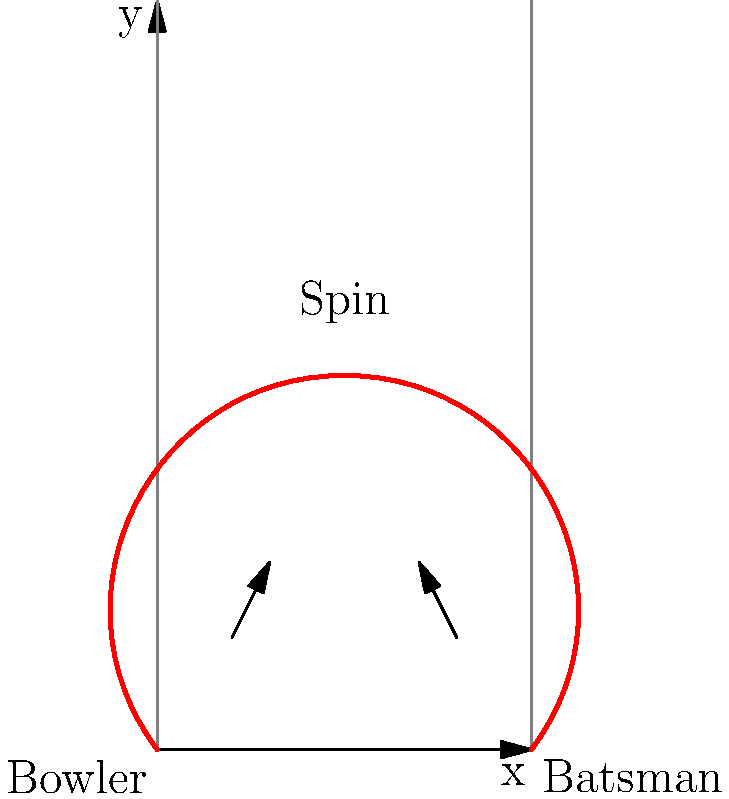In a spin bowling delivery, the cricket ball's trajectory typically follows a curved path. Based on the diagram, which mathematical function best describes the ball's path, and how does this relate to the Magnus effect in cricket? To understand the trajectory of a cricket ball during a spin bowling delivery, let's break it down step-by-step:

1. Shape of the trajectory: The path shown in the diagram resembles a parabola, which is typically represented by a quadratic function.

2. Quadratic function: The general form of a quadratic function is $f(x) = ax^2 + bx + c$, where $a$, $b$, and $c$ are constants, and $a \neq 0$.

3. Physics behind the trajectory:
   a) Gravity: Pulls the ball downward, contributing to the parabolic shape.
   b) Initial velocity: Imparted by the bowler, gives the ball its initial trajectory.
   c) Spin: Causes the Magnus effect, which influences the ball's path.

4. Magnus effect: This is the phenomenon where a spinning object creates a pressure difference in the surrounding fluid (in this case, air), resulting in a force perpendicular to the direction of motion.

5. In cricket:
   a) For a ball spinning from left to right (off-spin), the Magnus effect causes the ball to drift from right to left in the air.
   b) For a ball spinning from right to left (leg-spin), the drift is from left to right.

6. Mathematical representation: The trajectory can be approximated by:

   $$y = -a(x-h)^2 + k$$

   Where $(h,k)$ is the vertex of the parabola, and $a$ is a positive constant determining the parabola's width.

7. Relation to Magnus effect: The Magnus effect influences the values of $h$ and $k$ in the equation, shifting the parabola's position and potentially affecting its shape slightly.

In conclusion, while the basic shape is parabolic due to gravity and initial velocity, the Magnus effect from the spin subtly alters this path, creating the characteristic curved trajectory of a spin bowling delivery.
Answer: Quadratic function, modified by Magnus effect 